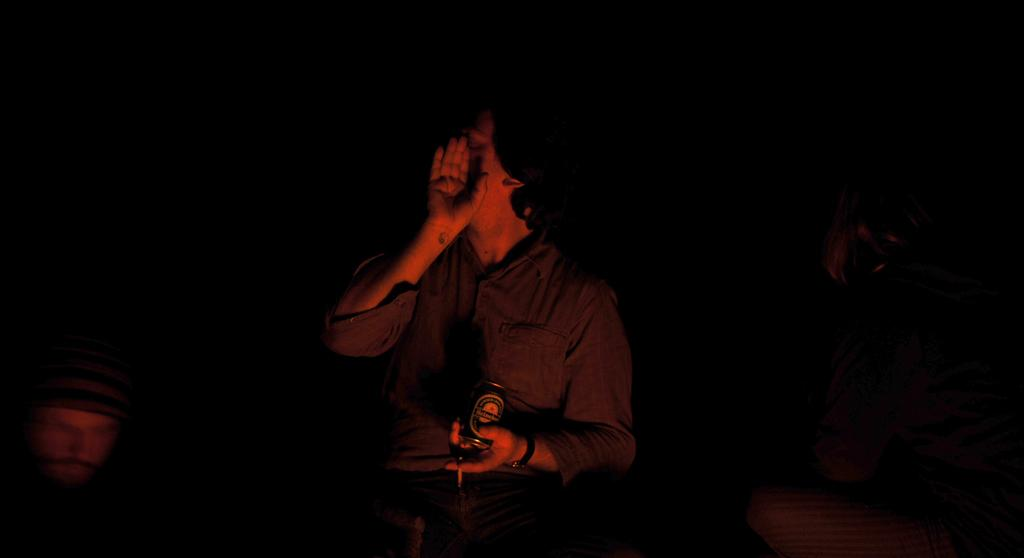Who is present in the image? There is a man in the image. What is the man holding in the image? The man is holding a bottle. Can you describe the lighting in the image? The image is dark. What type of test is the man conducting in the image? There is no indication in the image that the man is conducting a test, as he is simply holding a bottle. Can you see a robin in the image? There is no robin present in the image. 